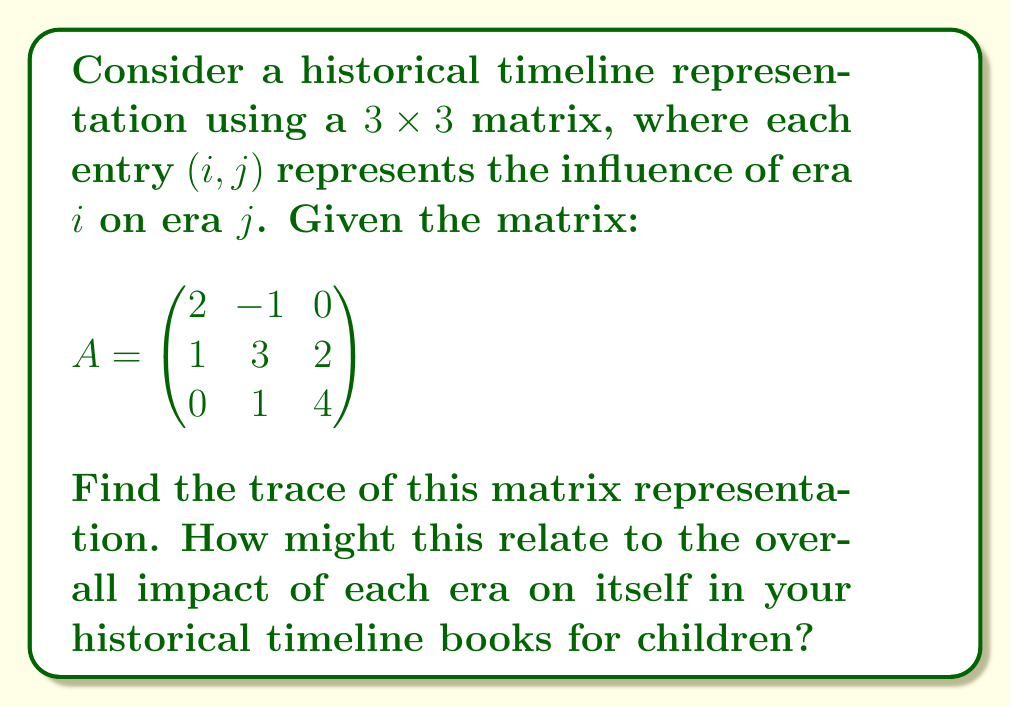Solve this math problem. To find the trace of a matrix, we sum the elements along the main diagonal (from top-left to bottom-right). Let's break it down step-by-step:

1) The main diagonal elements of matrix $A$ are:
   $a_{11} = 2$
   $a_{22} = 3$
   $a_{33} = 4$

2) The trace of a matrix is defined as:
   $\text{tr}(A) = \sum_{i=1}^n a_{ii}$

3) For our 3x3 matrix:
   $\text{tr}(A) = a_{11} + a_{22} + a_{33}$

4) Substituting the values:
   $\text{tr}(A) = 2 + 3 + 4 = 9$

In the context of historical timelines for children's books, this trace could represent the cumulative self-influence of each era. A higher trace value might indicate that each era had a strong impact on its own development, which could be an interesting point to discuss in the books.
Answer: $\text{tr}(A) = 9$ 